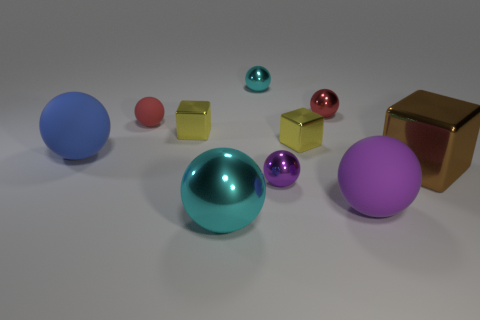Subtract all cyan balls. How many balls are left? 5 Subtract all big purple spheres. How many spheres are left? 6 Subtract all purple balls. Subtract all green cubes. How many balls are left? 5 Subtract all blocks. How many objects are left? 7 Subtract all red matte spheres. Subtract all small cyan spheres. How many objects are left? 8 Add 3 blue things. How many blue things are left? 4 Add 10 green metal things. How many green metal things exist? 10 Subtract 0 blue blocks. How many objects are left? 10 